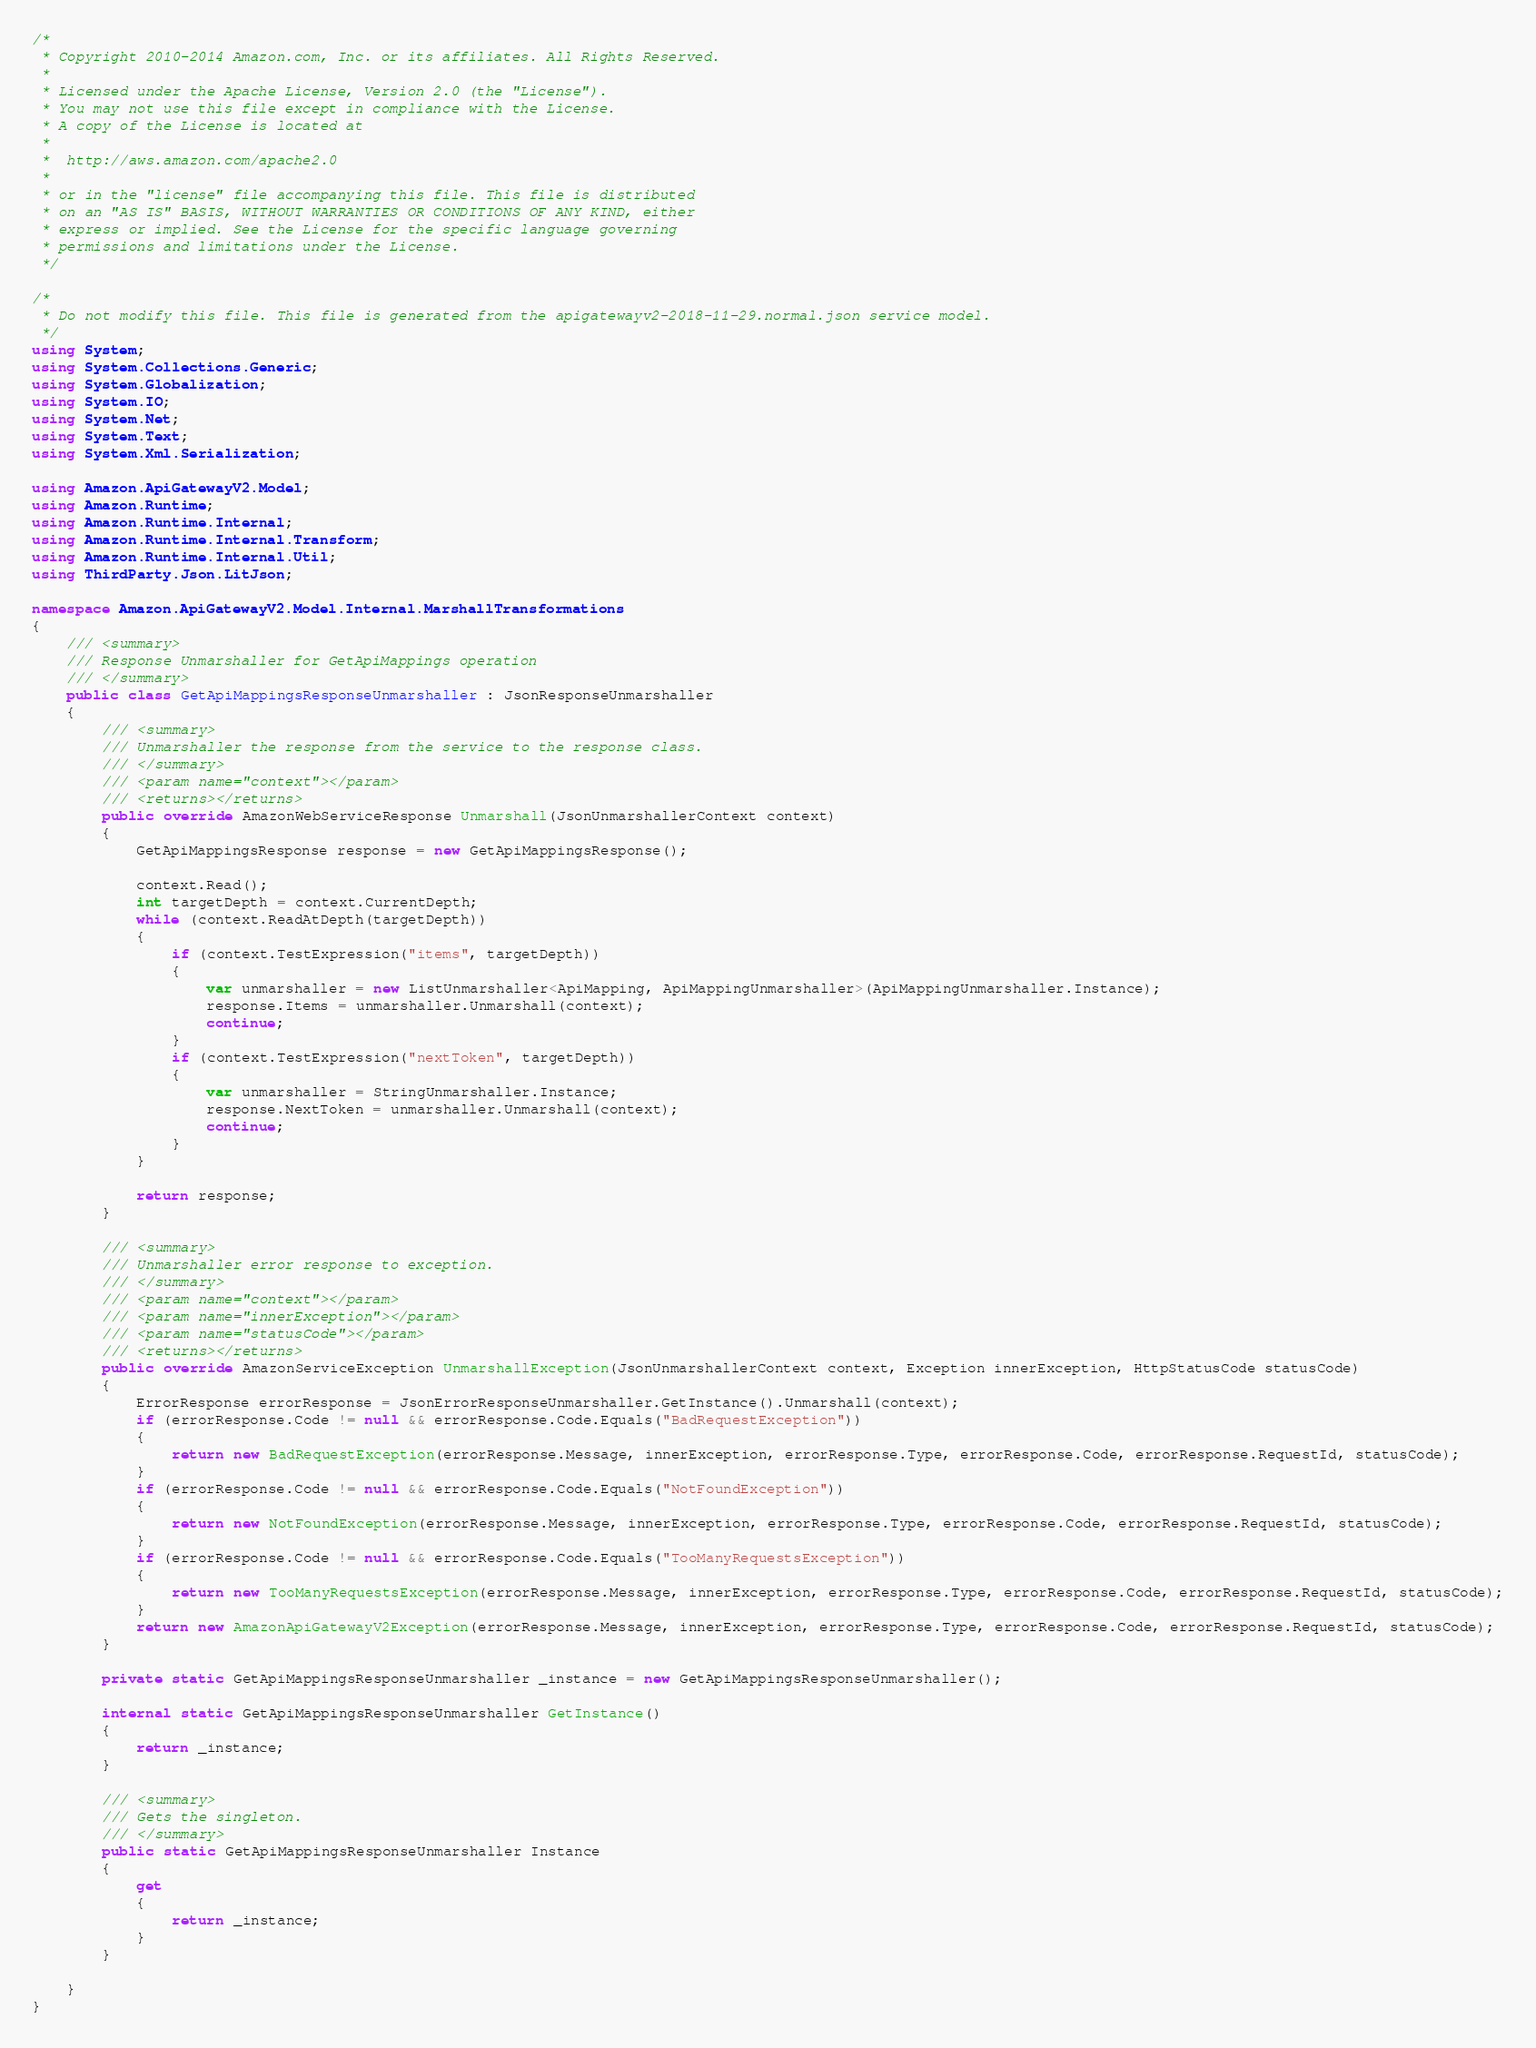Convert code to text. <code><loc_0><loc_0><loc_500><loc_500><_C#_>/*
 * Copyright 2010-2014 Amazon.com, Inc. or its affiliates. All Rights Reserved.
 * 
 * Licensed under the Apache License, Version 2.0 (the "License").
 * You may not use this file except in compliance with the License.
 * A copy of the License is located at
 * 
 *  http://aws.amazon.com/apache2.0
 * 
 * or in the "license" file accompanying this file. This file is distributed
 * on an "AS IS" BASIS, WITHOUT WARRANTIES OR CONDITIONS OF ANY KIND, either
 * express or implied. See the License for the specific language governing
 * permissions and limitations under the License.
 */

/*
 * Do not modify this file. This file is generated from the apigatewayv2-2018-11-29.normal.json service model.
 */
using System;
using System.Collections.Generic;
using System.Globalization;
using System.IO;
using System.Net;
using System.Text;
using System.Xml.Serialization;

using Amazon.ApiGatewayV2.Model;
using Amazon.Runtime;
using Amazon.Runtime.Internal;
using Amazon.Runtime.Internal.Transform;
using Amazon.Runtime.Internal.Util;
using ThirdParty.Json.LitJson;

namespace Amazon.ApiGatewayV2.Model.Internal.MarshallTransformations
{
    /// <summary>
    /// Response Unmarshaller for GetApiMappings operation
    /// </summary>  
    public class GetApiMappingsResponseUnmarshaller : JsonResponseUnmarshaller
    {
        /// <summary>
        /// Unmarshaller the response from the service to the response class.
        /// </summary>  
        /// <param name="context"></param>
        /// <returns></returns>
        public override AmazonWebServiceResponse Unmarshall(JsonUnmarshallerContext context)
        {
            GetApiMappingsResponse response = new GetApiMappingsResponse();

            context.Read();
            int targetDepth = context.CurrentDepth;
            while (context.ReadAtDepth(targetDepth))
            {
                if (context.TestExpression("items", targetDepth))
                {
                    var unmarshaller = new ListUnmarshaller<ApiMapping, ApiMappingUnmarshaller>(ApiMappingUnmarshaller.Instance);
                    response.Items = unmarshaller.Unmarshall(context);
                    continue;
                }
                if (context.TestExpression("nextToken", targetDepth))
                {
                    var unmarshaller = StringUnmarshaller.Instance;
                    response.NextToken = unmarshaller.Unmarshall(context);
                    continue;
                }
            }

            return response;
        }

        /// <summary>
        /// Unmarshaller error response to exception.
        /// </summary>  
        /// <param name="context"></param>
        /// <param name="innerException"></param>
        /// <param name="statusCode"></param>
        /// <returns></returns>
        public override AmazonServiceException UnmarshallException(JsonUnmarshallerContext context, Exception innerException, HttpStatusCode statusCode)
        {
            ErrorResponse errorResponse = JsonErrorResponseUnmarshaller.GetInstance().Unmarshall(context);
            if (errorResponse.Code != null && errorResponse.Code.Equals("BadRequestException"))
            {
                return new BadRequestException(errorResponse.Message, innerException, errorResponse.Type, errorResponse.Code, errorResponse.RequestId, statusCode);
            }
            if (errorResponse.Code != null && errorResponse.Code.Equals("NotFoundException"))
            {
                return new NotFoundException(errorResponse.Message, innerException, errorResponse.Type, errorResponse.Code, errorResponse.RequestId, statusCode);
            }
            if (errorResponse.Code != null && errorResponse.Code.Equals("TooManyRequestsException"))
            {
                return new TooManyRequestsException(errorResponse.Message, innerException, errorResponse.Type, errorResponse.Code, errorResponse.RequestId, statusCode);
            }
            return new AmazonApiGatewayV2Exception(errorResponse.Message, innerException, errorResponse.Type, errorResponse.Code, errorResponse.RequestId, statusCode);
        }

        private static GetApiMappingsResponseUnmarshaller _instance = new GetApiMappingsResponseUnmarshaller();        

        internal static GetApiMappingsResponseUnmarshaller GetInstance()
        {
            return _instance;
        }

        /// <summary>
        /// Gets the singleton.
        /// </summary>  
        public static GetApiMappingsResponseUnmarshaller Instance
        {
            get
            {
                return _instance;
            }
        }

    }
}</code> 